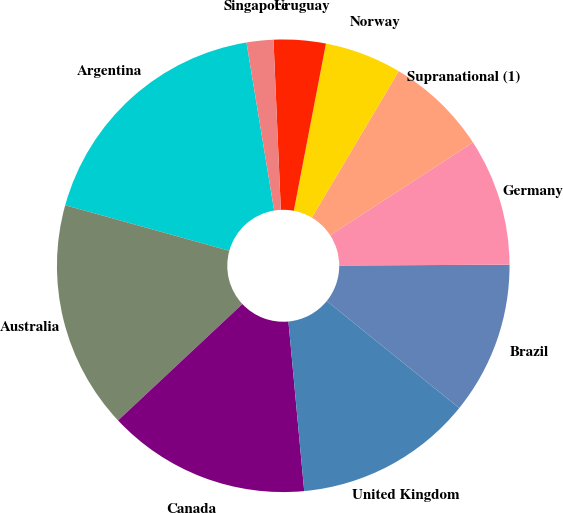Convert chart. <chart><loc_0><loc_0><loc_500><loc_500><pie_chart><fcel>Argentina<fcel>Australia<fcel>Canada<fcel>United Kingdom<fcel>Brazil<fcel>Germany<fcel>Supranational (1)<fcel>Norway<fcel>Uruguay<fcel>Singapore<nl><fcel>18.09%<fcel>16.29%<fcel>14.5%<fcel>12.7%<fcel>10.9%<fcel>9.1%<fcel>7.3%<fcel>5.5%<fcel>3.71%<fcel>1.91%<nl></chart> 